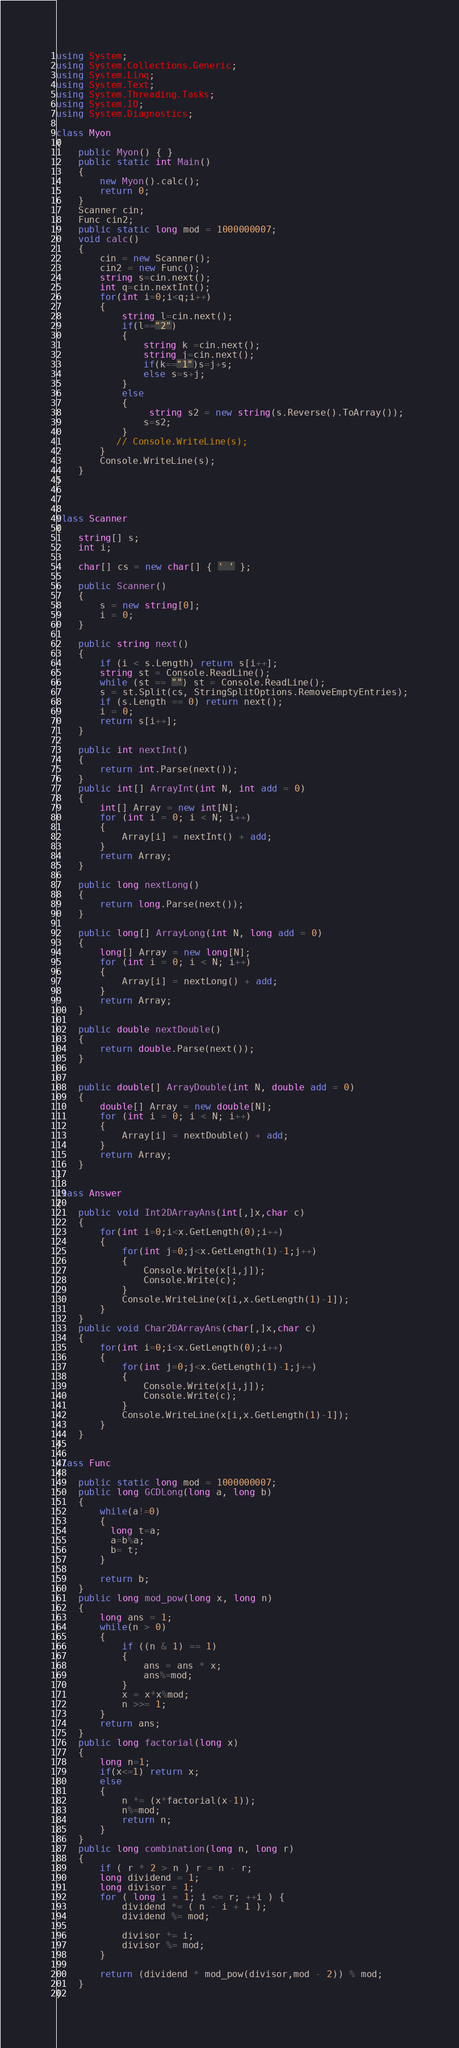Convert code to text. <code><loc_0><loc_0><loc_500><loc_500><_C#_>using System;
using System.Collections.Generic;
using System.Linq;
using System.Text;
using System.Threading.Tasks;
using System.IO;
using System.Diagnostics;

class Myon
{
    public Myon() { }
    public static int Main()
    {
        new Myon().calc();
        return 0;
    }
    Scanner cin;
    Func cin2;
    public static long mod = 1000000007;
    void calc()
    {
        cin = new Scanner();
        cin2 = new Func();
        string s=cin.next();
        int q=cin.nextInt();
        for(int i=0;i<q;i++)
        {
            string l=cin.next();
            if(l=="2")
            {
                string k =cin.next();
                string j=cin.next();
                if(k=="1")s=j+s;
                else s=s+j;
            }
            else 
            {
                 string s2 = new string(s.Reverse().ToArray());
                s=s2;
            }
           // Console.WriteLine(s);
        }
        Console.WriteLine(s);
    }
}



class Scanner
{
    string[] s;
    int i;

    char[] cs = new char[] { ' ' };

    public Scanner()
    {
        s = new string[0];
        i = 0;
    }

    public string next()
    {
        if (i < s.Length) return s[i++];
        string st = Console.ReadLine();
        while (st == "") st = Console.ReadLine();
        s = st.Split(cs, StringSplitOptions.RemoveEmptyEntries);
        if (s.Length == 0) return next();
        i = 0;
        return s[i++];
    }

    public int nextInt()
    {
        return int.Parse(next());
    }
    public int[] ArrayInt(int N, int add = 0)
    {
        int[] Array = new int[N];
        for (int i = 0; i < N; i++)
        {
            Array[i] = nextInt() + add;
        }
        return Array;
    }

    public long nextLong()
    {
        return long.Parse(next());
    }

    public long[] ArrayLong(int N, long add = 0)
    {
        long[] Array = new long[N];
        for (int i = 0; i < N; i++)
        {
            Array[i] = nextLong() + add;
        }
        return Array;
    }

    public double nextDouble()
    {
        return double.Parse(next());
    }


    public double[] ArrayDouble(int N, double add = 0)
    {
        double[] Array = new double[N];
        for (int i = 0; i < N; i++)
        {
            Array[i] = nextDouble() + add;
        }
        return Array;
    }
}

class Answer
{
    public void Int2DArrayAns(int[,]x,char c)
    {
        for(int i=0;i<x.GetLength(0);i++)
        {
            for(int j=0;j<x.GetLength(1)-1;j++)
            {
                Console.Write(x[i,j]);
                Console.Write(c);
            }
            Console.WriteLine(x[i,x.GetLength(1)-1]);
        }
    }
    public void Char2DArrayAns(char[,]x,char c)
    {
        for(int i=0;i<x.GetLength(0);i++)
        {
            for(int j=0;j<x.GetLength(1)-1;j++)
            {
                Console.Write(x[i,j]);
                Console.Write(c);
            }
            Console.WriteLine(x[i,x.GetLength(1)-1]);
        }
    }
}

class Func
{
    public static long mod = 1000000007;
    public long GCDLong(long a, long b)
    {
        while(a!=0)
        {
          long t=a;
          a=b%a;
          b= t;
        }
      
        return b;        
    }
    public long mod_pow(long x, long n)
    { 
        long ans = 1;
        while(n > 0)
        {
            if ((n & 1) == 1)
            {
                ans = ans * x;
                ans%=mod;
            }
            x = x*x%mod;
            n >>= 1;
        }
        return ans;
    }
    public long factorial(long x)
    {
        long n=1;
        if(x<=1) return x;
        else
        {
            n *= (x*factorial(x-1));
            n%=mod;
            return n;
        }
    }
    public long combination(long n, long r)
    {
        if ( r * 2 > n ) r = n - r;
		long dividend = 1;
		long divisor = 1;
		for ( long i = 1; i <= r; ++i ) {
			dividend *= ( n - i + 1 );
			dividend %= mod;
 
			divisor *= i;
			divisor %= mod;
		}
 
		return (dividend * mod_pow(divisor,mod - 2)) % mod;   
    }
}


</code> 